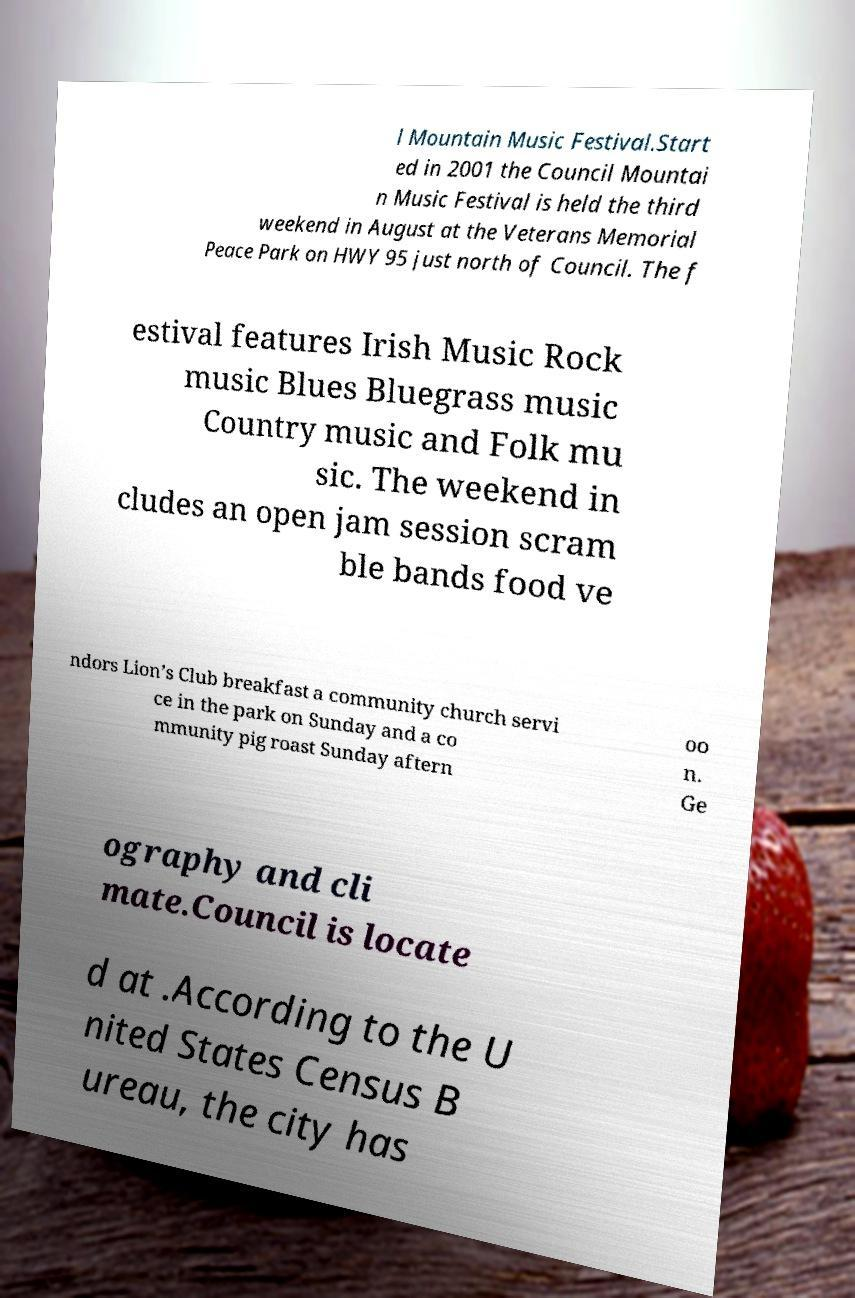Can you read and provide the text displayed in the image?This photo seems to have some interesting text. Can you extract and type it out for me? l Mountain Music Festival.Start ed in 2001 the Council Mountai n Music Festival is held the third weekend in August at the Veterans Memorial Peace Park on HWY 95 just north of Council. The f estival features Irish Music Rock music Blues Bluegrass music Country music and Folk mu sic. The weekend in cludes an open jam session scram ble bands food ve ndors Lion’s Club breakfast a community church servi ce in the park on Sunday and a co mmunity pig roast Sunday aftern oo n. Ge ography and cli mate.Council is locate d at .According to the U nited States Census B ureau, the city has 